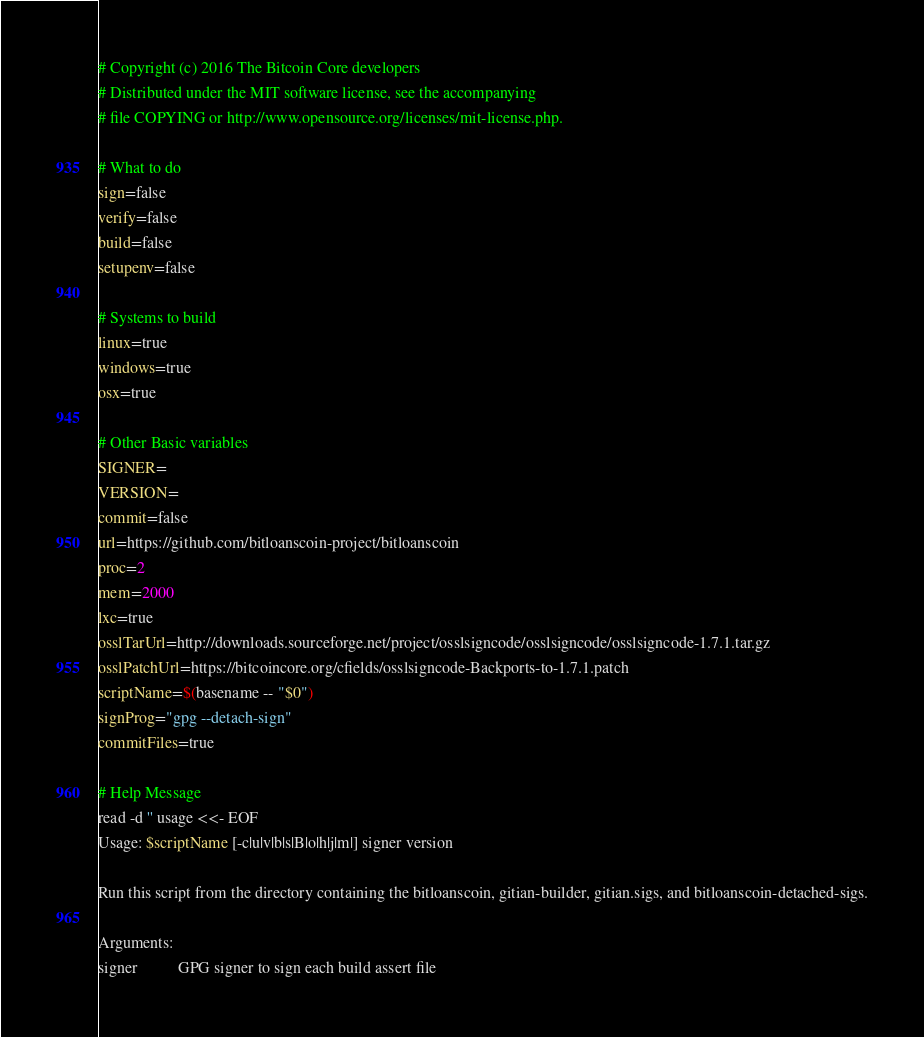<code> <loc_0><loc_0><loc_500><loc_500><_Bash_># Copyright (c) 2016 The Bitcoin Core developers
# Distributed under the MIT software license, see the accompanying
# file COPYING or http://www.opensource.org/licenses/mit-license.php.

# What to do
sign=false
verify=false
build=false
setupenv=false

# Systems to build
linux=true
windows=true
osx=true

# Other Basic variables
SIGNER=
VERSION=
commit=false
url=https://github.com/bitloanscoin-project/bitloanscoin
proc=2
mem=2000
lxc=true
osslTarUrl=http://downloads.sourceforge.net/project/osslsigncode/osslsigncode/osslsigncode-1.7.1.tar.gz
osslPatchUrl=https://bitcoincore.org/cfields/osslsigncode-Backports-to-1.7.1.patch
scriptName=$(basename -- "$0")
signProg="gpg --detach-sign"
commitFiles=true

# Help Message
read -d '' usage <<- EOF
Usage: $scriptName [-c|u|v|b|s|B|o|h|j|m|] signer version

Run this script from the directory containing the bitloanscoin, gitian-builder, gitian.sigs, and bitloanscoin-detached-sigs.

Arguments:
signer          GPG signer to sign each build assert file</code> 